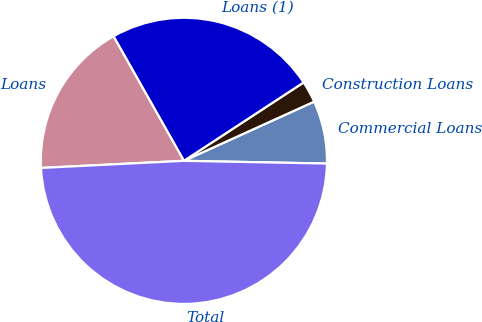<chart> <loc_0><loc_0><loc_500><loc_500><pie_chart><fcel>Commercial Loans<fcel>Construction Loans<fcel>Loans (1)<fcel>Loans<fcel>Total<nl><fcel>7.09%<fcel>2.44%<fcel>23.96%<fcel>17.6%<fcel>48.9%<nl></chart> 